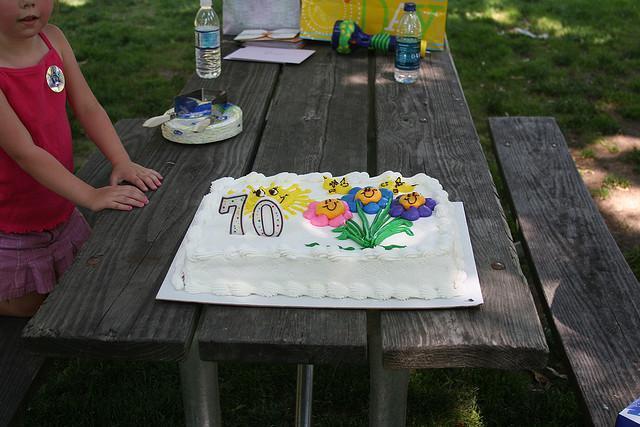Does the image validate the caption "The cake is at the right side of the person."?
Answer yes or no. Yes. 